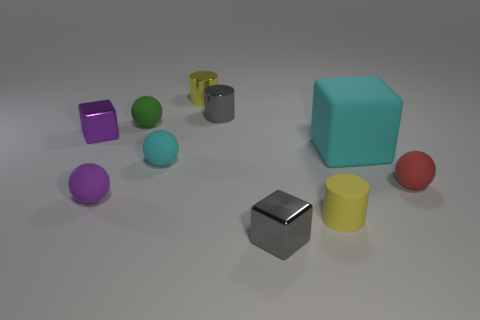How many things are either small rubber things that are in front of the purple block or tiny objects that are behind the tiny purple metallic block?
Your answer should be very brief. 7. There is a tiny purple object that is the same shape as the red rubber object; what is its material?
Offer a very short reply. Rubber. How many rubber objects are purple blocks or tiny yellow cylinders?
Your response must be concise. 1. There is a small green object that is made of the same material as the purple sphere; what shape is it?
Your answer should be very brief. Sphere. What number of small cyan rubber objects have the same shape as the small red rubber thing?
Provide a succinct answer. 1. Do the tiny gray thing in front of the red ball and the yellow thing that is in front of the tiny red rubber object have the same shape?
Ensure brevity in your answer.  No. What number of things are big matte blocks or small rubber balls that are in front of the big cyan matte cube?
Your answer should be very brief. 4. What is the shape of the thing that is the same color as the big rubber cube?
Make the answer very short. Sphere. What number of shiny spheres are the same size as the red thing?
Keep it short and to the point. 0. What number of yellow objects are either objects or cylinders?
Offer a very short reply. 2. 